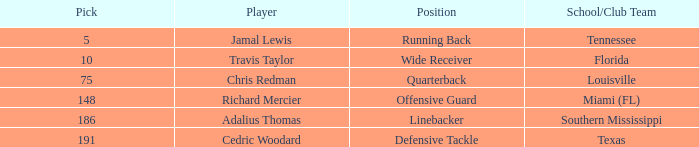What's the highest round that louisville drafted into when their pick was over 75? None. 